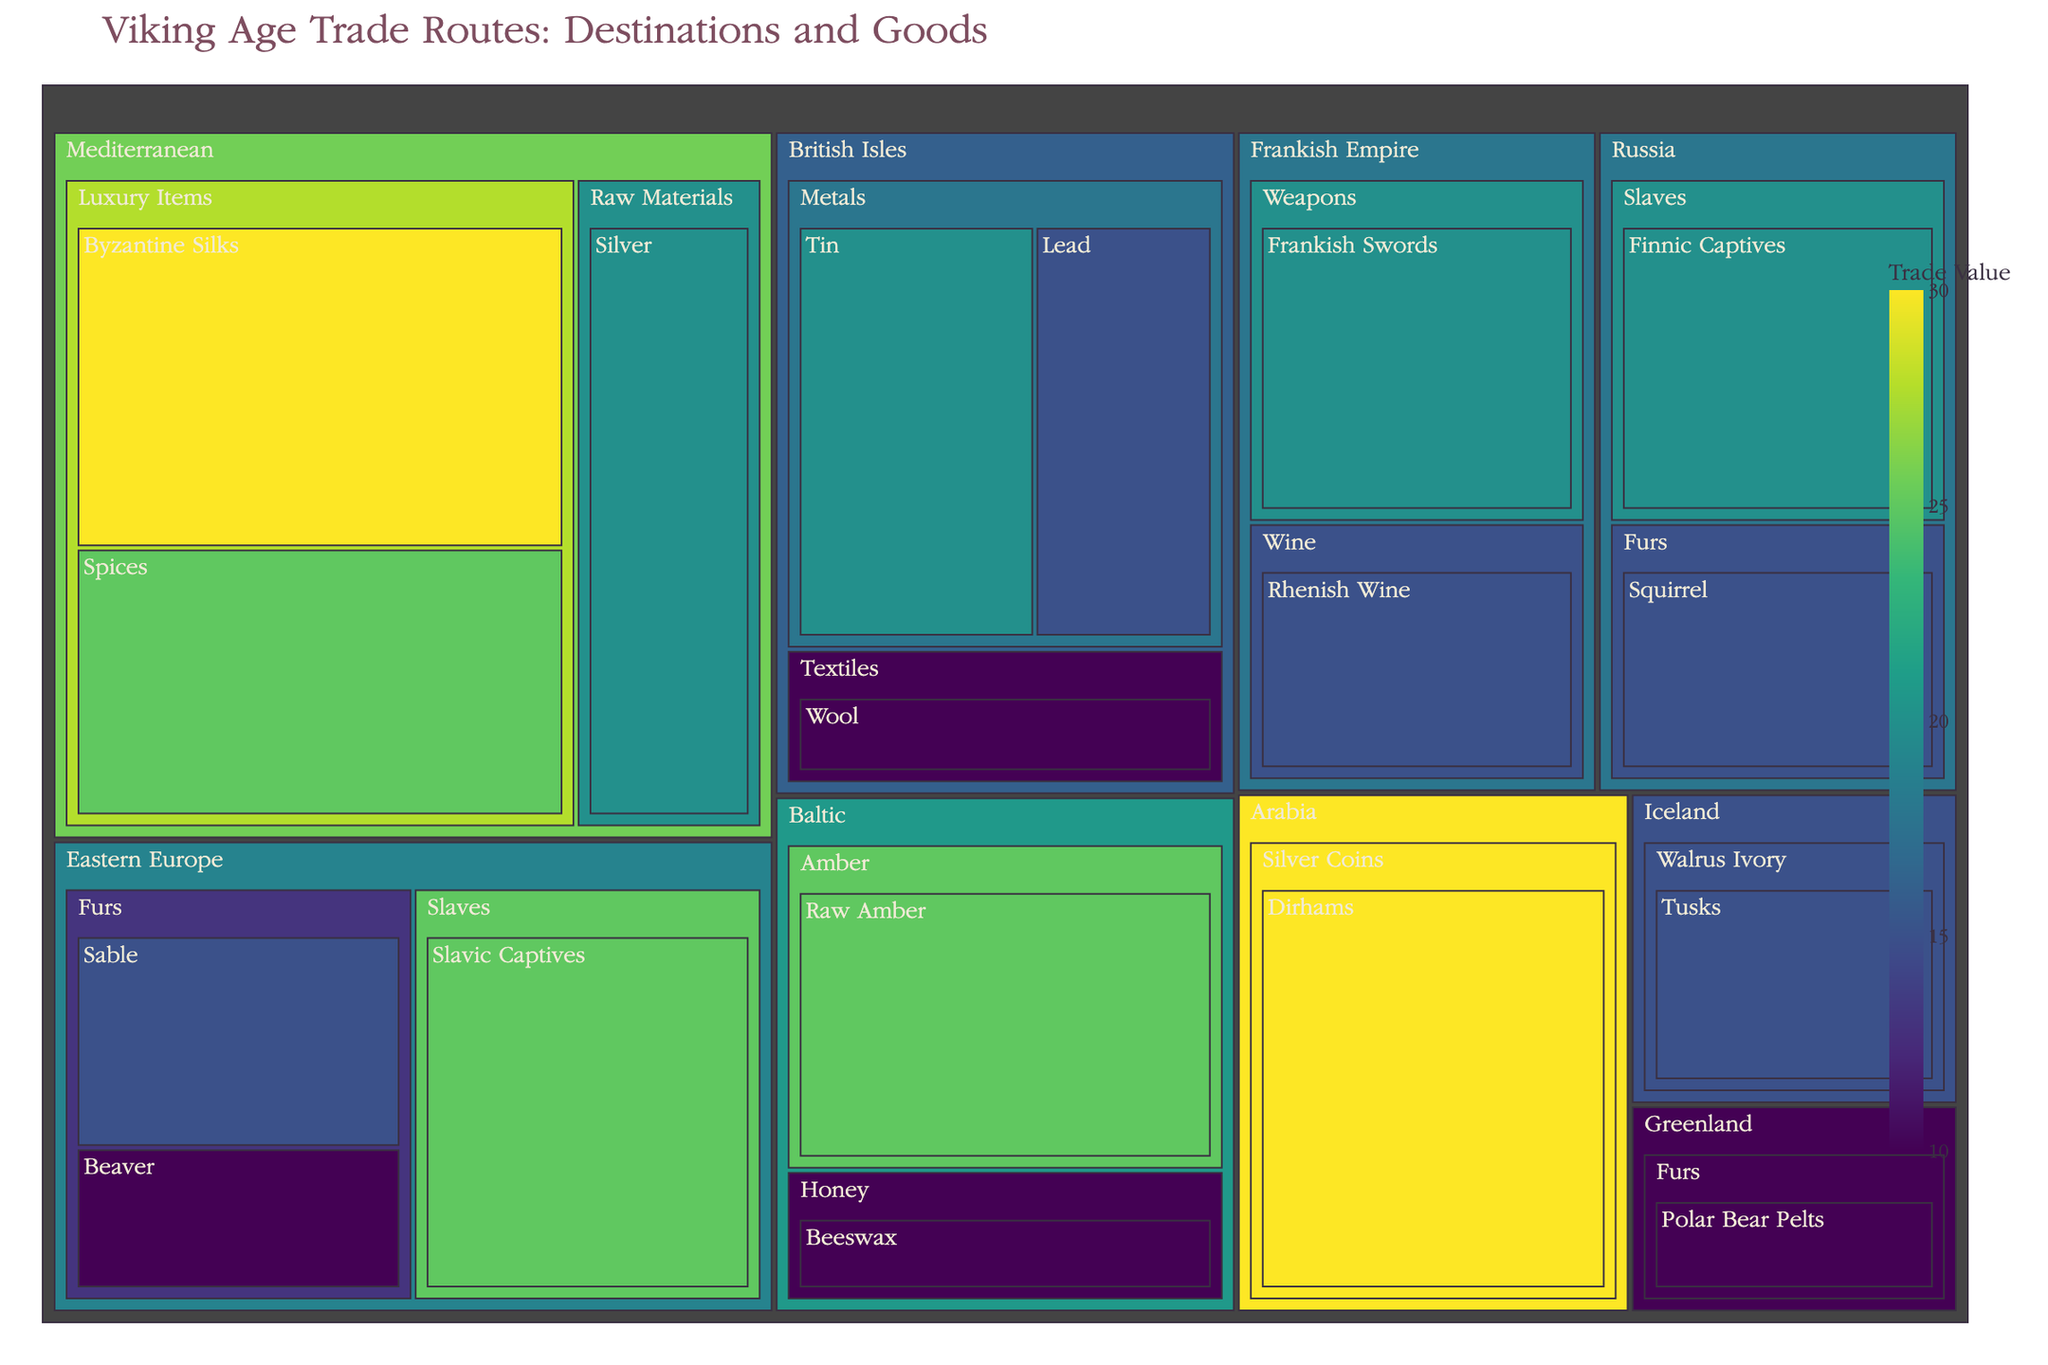What's the title of the treemap? The title is found at the top of the treemap, summarizing its content. This helps to quickly understand what the figure represents.
Answer: Viking Age Trade Routes: Destinations and Goods Which trading destination has the highest total trade value? By looking at the sizes of the rectangles representing different destinations, the destination with the largest total value can be identified.
Answer: Mediterranean What is the total value of Luxury Items traded to the Mediterranean? Add up the values of Byzantine Silks and Spices under the Luxury Items category for the Mediterranean destination. 30 + 25 = 55.
Answer: 55 Which category in Eastern Europe has the highest trade value? Compare the trade values of different categories under Eastern Europe: Furs, Slaves, etc., and identify the highest.
Answer: Slaves Is the value of tin traded to the British Isles greater than the value of Byzantine Silks traded to the Mediterranean? Compare the values of tin (20) and Byzantine Silks (30) to determine which is greater.
Answer: No Which category of goods does Arabia trade the most? The largest rectangle under the "Arabia" destination represents the highest category.
Answer: Silver Coins How does the trade value of Silver to the Mediterranean compare to the trade value of Rhenish Wine to the Frankish Empire? Compare the silver trade value (20) with the wine trade value (15) and determine which is greater.
Answer: Silver to the Mediterranean Calculate the total trade value for Furs across all destinations. Summing up all trade values under the Furs category:
15 (Sable, Eastern Europe) + 10 (Beaver, Eastern Europe) + 10 (Polar Bear Pelts, Greenland) + 15 (Squirrel, Russia) = 50.
Answer: 50 Which destination trades more Slaves: Eastern Europe or Russia? Compare the trade values of Slaves: 25 (Eastern Europe) and 20 (Russia).
Answer: Eastern Europe 